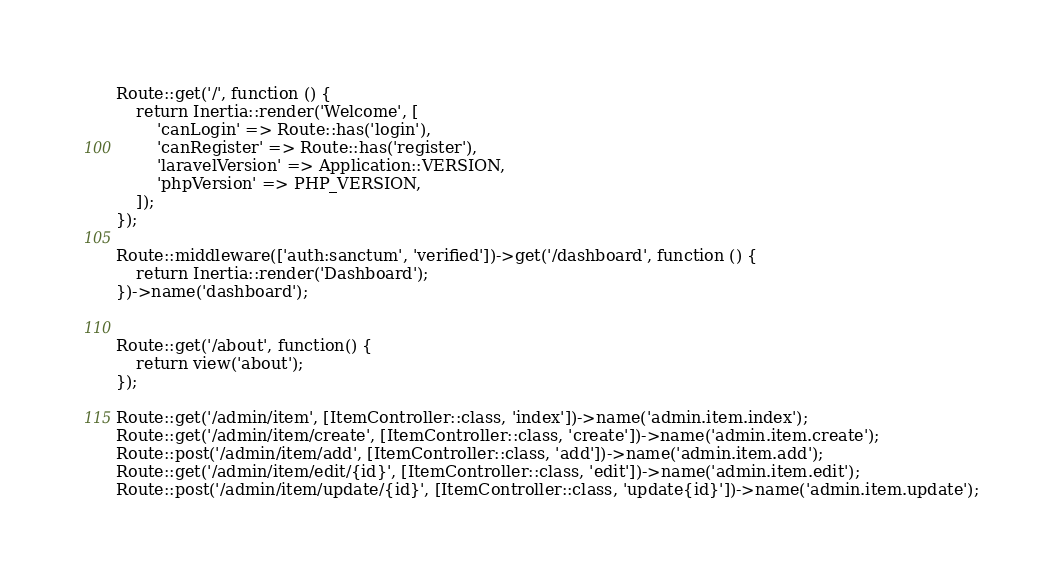Convert code to text. <code><loc_0><loc_0><loc_500><loc_500><_PHP_>
Route::get('/', function () {
    return Inertia::render('Welcome', [
        'canLogin' => Route::has('login'),
        'canRegister' => Route::has('register'),
        'laravelVersion' => Application::VERSION,
        'phpVersion' => PHP_VERSION,
    ]);
});

Route::middleware(['auth:sanctum', 'verified'])->get('/dashboard', function () {
    return Inertia::render('Dashboard');
})->name('dashboard');


Route::get('/about', function() {
    return view('about');
});

Route::get('/admin/item', [ItemController::class, 'index'])->name('admin.item.index');
Route::get('/admin/item/create', [ItemController::class, 'create'])->name('admin.item.create');
Route::post('/admin/item/add', [ItemController::class, 'add'])->name('admin.item.add');
Route::get('/admin/item/edit/{id}', [ItemController::class, 'edit'])->name('admin.item.edit');
Route::post('/admin/item/update/{id}', [ItemController::class, 'update{id}'])->name('admin.item.update');</code> 